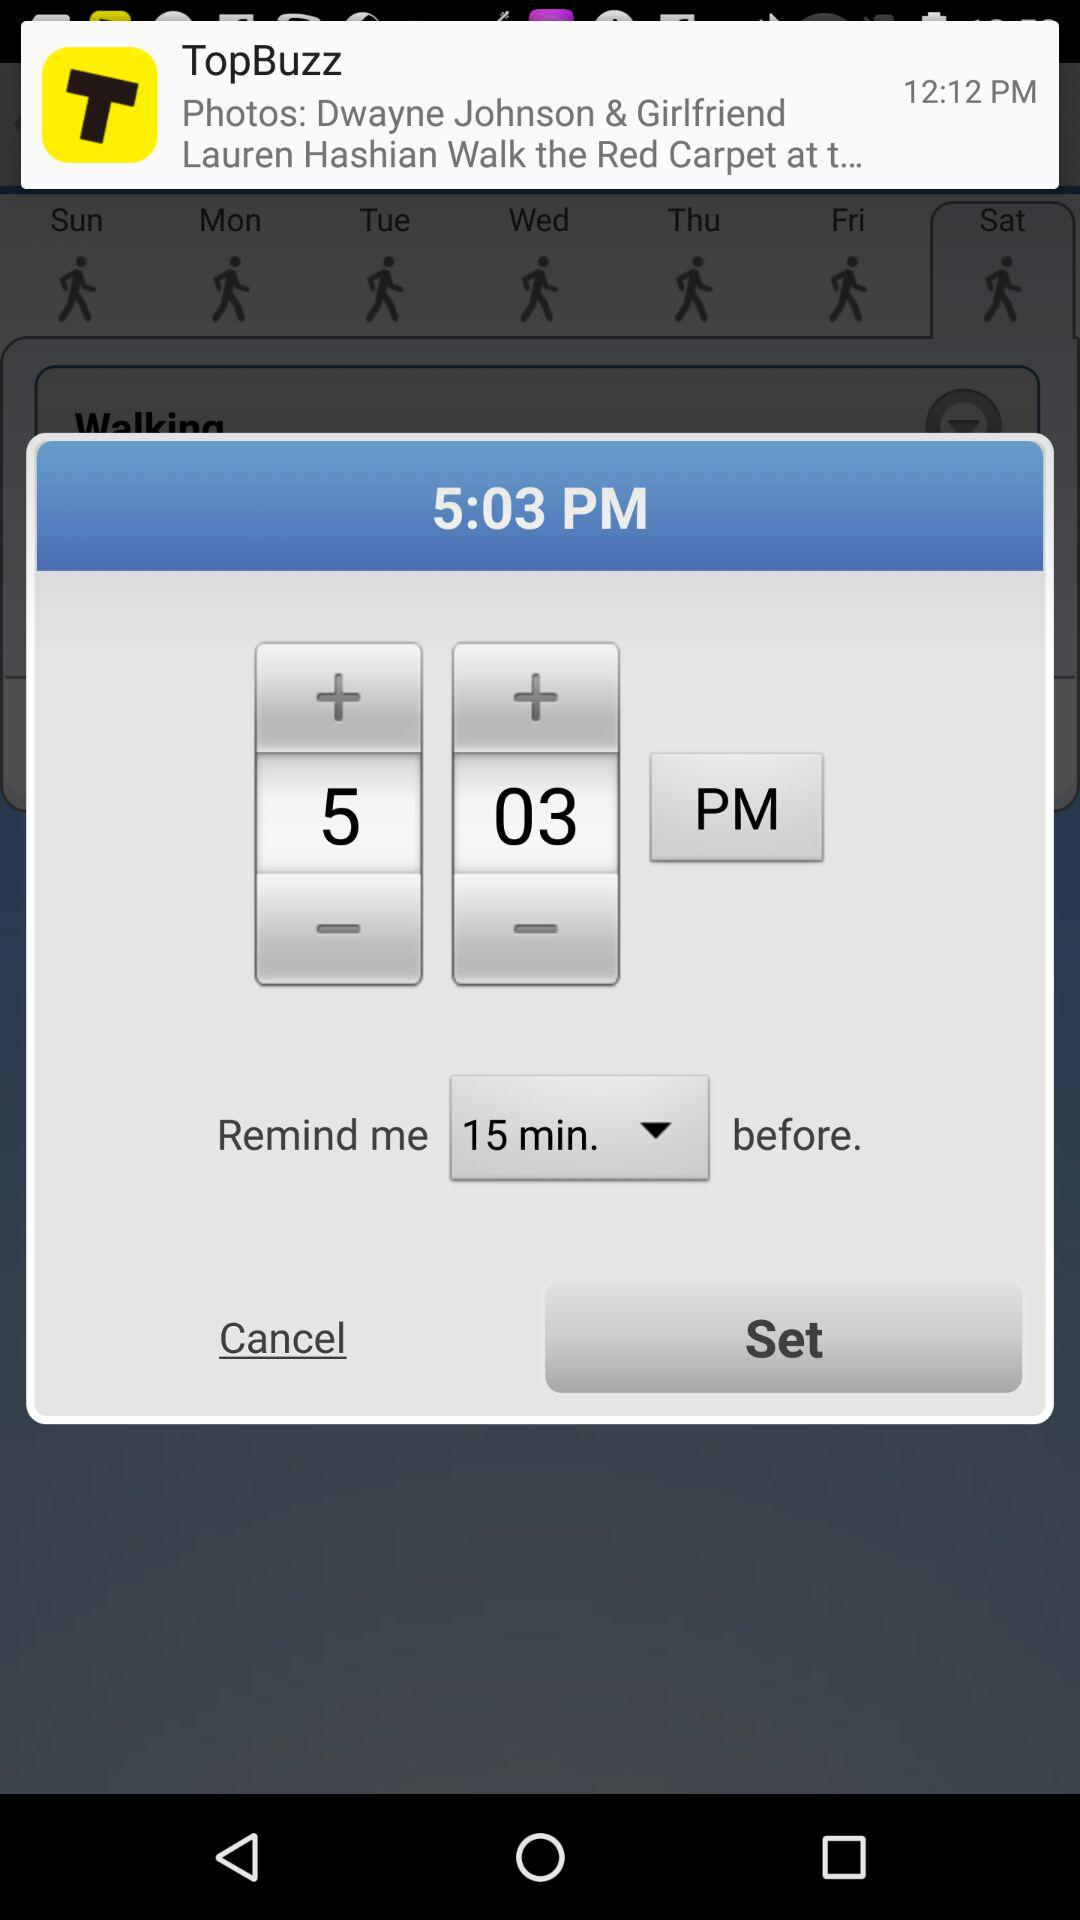What is the selected time? The selected time is 5:03 PM. 